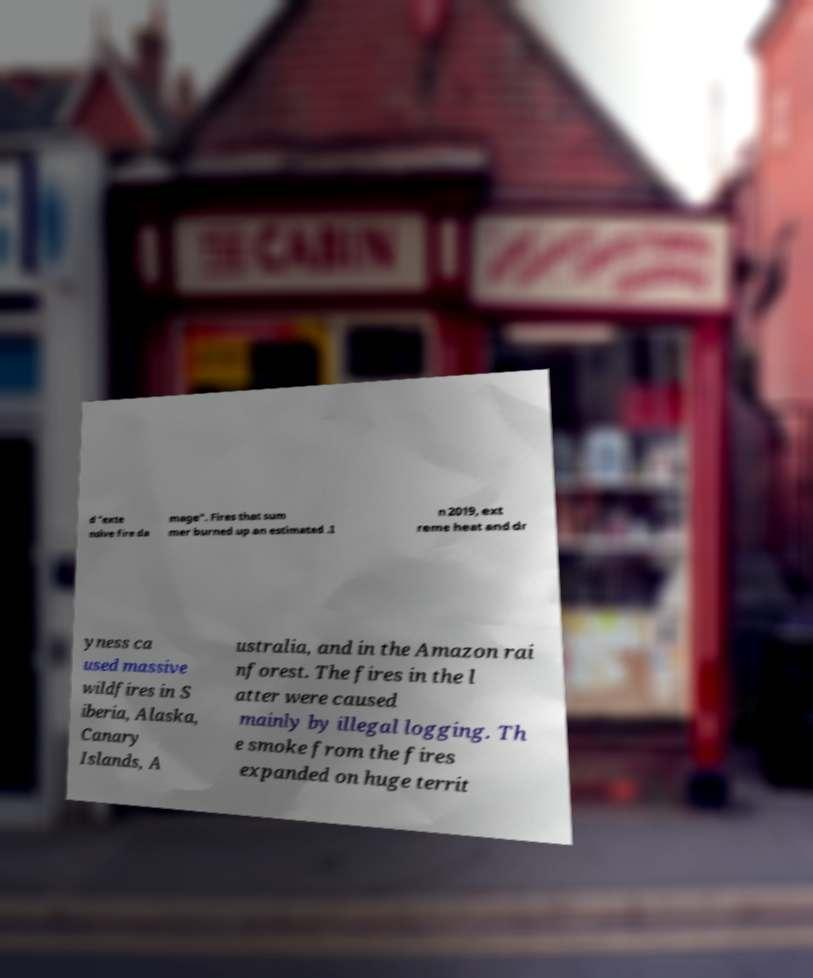Please identify and transcribe the text found in this image. d "exte nsive fire da mage". Fires that sum mer burned up an estimated .I n 2019, ext reme heat and dr yness ca used massive wildfires in S iberia, Alaska, Canary Islands, A ustralia, and in the Amazon rai nforest. The fires in the l atter were caused mainly by illegal logging. Th e smoke from the fires expanded on huge territ 